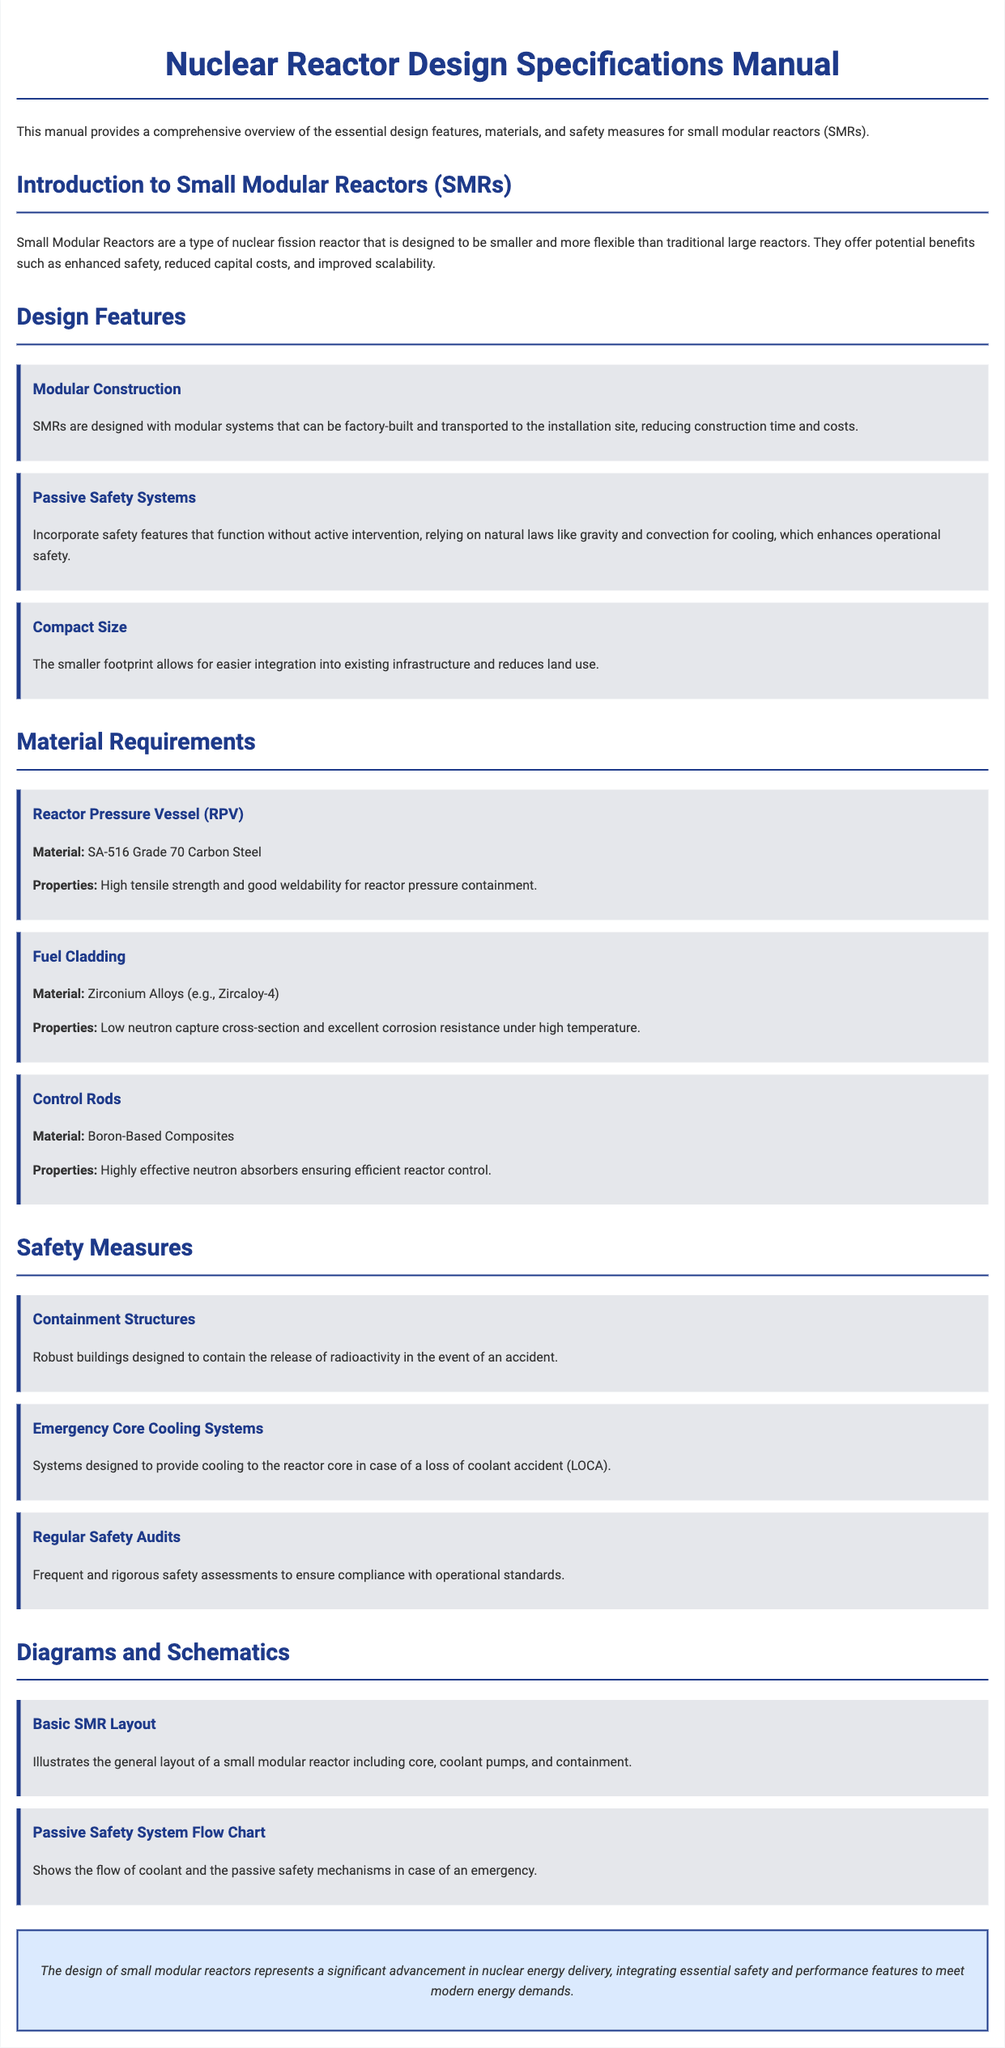What is the primary material used for the Reactor Pressure Vessel? The primary material is specified in the "Material Requirements" section under "Reactor Pressure Vessel," which states that it is SA-516 Grade 70 Carbon Steel.
Answer: SA-516 Grade 70 Carbon Steel What safety feature relies on natural laws like gravity and convection? This is mentioned in the "Design Features" section under "Passive Safety Systems," which describes their operation without active intervention.
Answer: Passive Safety Systems What is a benefit of the compact size of SMRs? The compact size allows for easier integration into existing infrastructure and reduces land use, as detailed in the "Design Features" section under "Compact Size."
Answer: Easier integration What material is used for Fuel Cladding? This information is found in the "Material Requirements" section where the material for Fuel Cladding is identified.
Answer: Zirconium Alloys What measure is designed to provide cooling in a loss of coolant accident? This is addressed in the "Safety Measures" section, specifically under "Emergency Core Cooling Systems."
Answer: Emergency Core Cooling Systems What is one of the main advantages of Small Modular Reactors according to the introduction? The introduction highlights potential benefits such as enhanced safety, reduced capital costs, and improved scalability.
Answer: Enhanced safety How often are regular safety audits conducted? The frequency of the safety audits is noted as "frequent and rigorous" in the "Safety Measures" section.
Answer: Frequent What is shown in the "Passive Safety System Flow Chart"? This chart illustrates the flow of coolant and the passive safety mechanisms, as described in the "Diagrams and Schematics" section.
Answer: Flow of coolant What is a key feature of SMRs regarding construction? This is outlined in the "Design Features" section under "Modular Construction," noting they can be factory-built.
Answer: Factory-built 